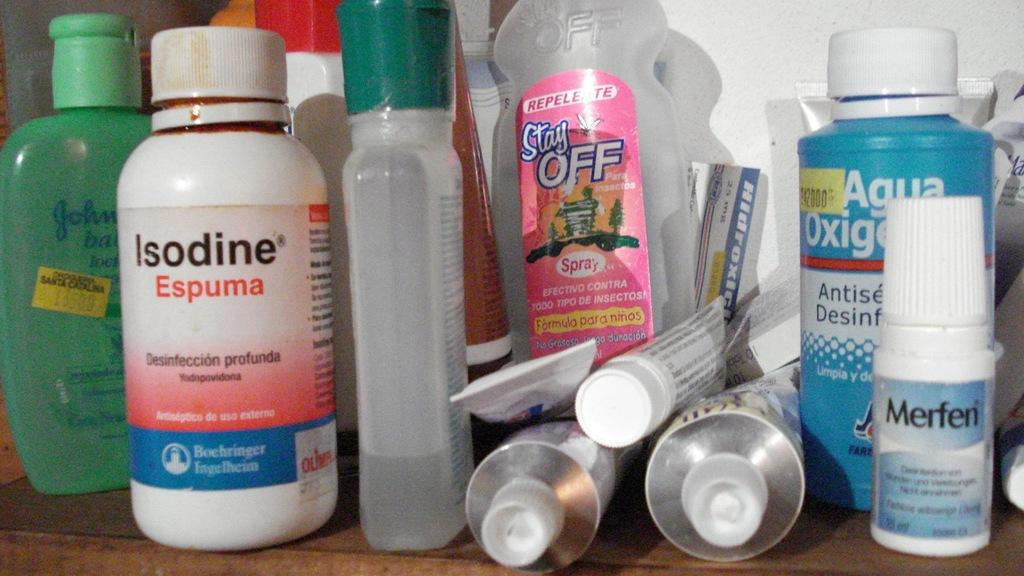<image>
Relay a brief, clear account of the picture shown. a bathroom shelf with a bottle of isodine espuma on it 